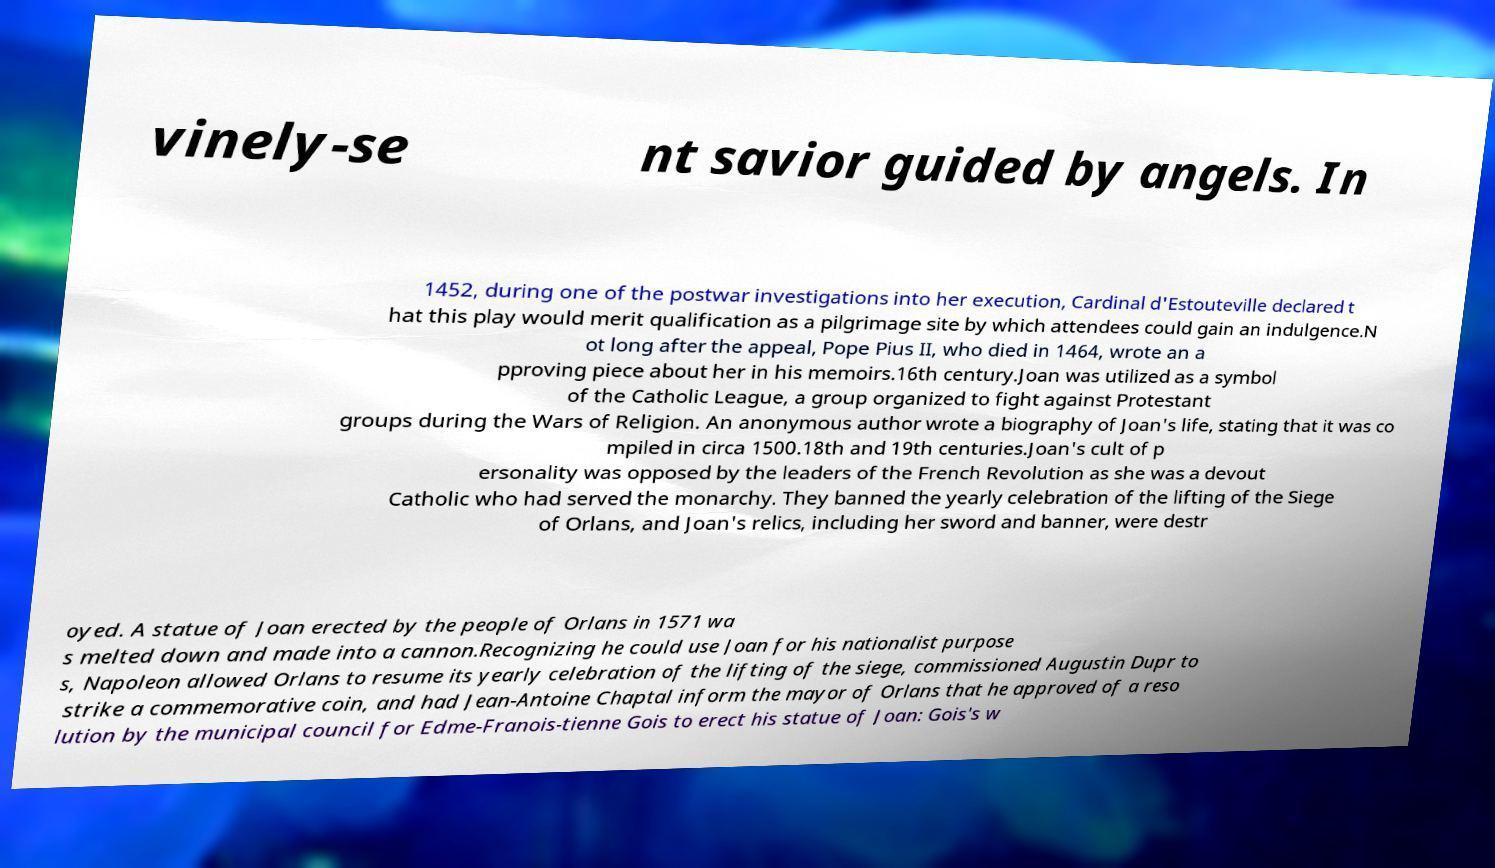There's text embedded in this image that I need extracted. Can you transcribe it verbatim? vinely-se nt savior guided by angels. In 1452, during one of the postwar investigations into her execution, Cardinal d'Estouteville declared t hat this play would merit qualification as a pilgrimage site by which attendees could gain an indulgence.N ot long after the appeal, Pope Pius II, who died in 1464, wrote an a pproving piece about her in his memoirs.16th century.Joan was utilized as a symbol of the Catholic League, a group organized to fight against Protestant groups during the Wars of Religion. An anonymous author wrote a biography of Joan's life, stating that it was co mpiled in circa 1500.18th and 19th centuries.Joan's cult of p ersonality was opposed by the leaders of the French Revolution as she was a devout Catholic who had served the monarchy. They banned the yearly celebration of the lifting of the Siege of Orlans, and Joan's relics, including her sword and banner, were destr oyed. A statue of Joan erected by the people of Orlans in 1571 wa s melted down and made into a cannon.Recognizing he could use Joan for his nationalist purpose s, Napoleon allowed Orlans to resume its yearly celebration of the lifting of the siege, commissioned Augustin Dupr to strike a commemorative coin, and had Jean-Antoine Chaptal inform the mayor of Orlans that he approved of a reso lution by the municipal council for Edme-Franois-tienne Gois to erect his statue of Joan: Gois's w 